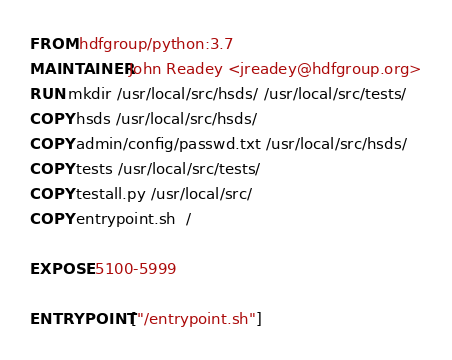<code> <loc_0><loc_0><loc_500><loc_500><_Dockerfile_>FROM hdfgroup/python:3.7
MAINTAINER John Readey <jreadey@hdfgroup.org>
RUN mkdir /usr/local/src/hsds/ /usr/local/src/tests/
COPY hsds /usr/local/src/hsds/
COPY admin/config/passwd.txt /usr/local/src/hsds/
COPY tests /usr/local/src/tests/
COPY testall.py /usr/local/src/
COPY entrypoint.sh  /

EXPOSE 5100-5999
 
ENTRYPOINT ["/entrypoint.sh"]</code> 